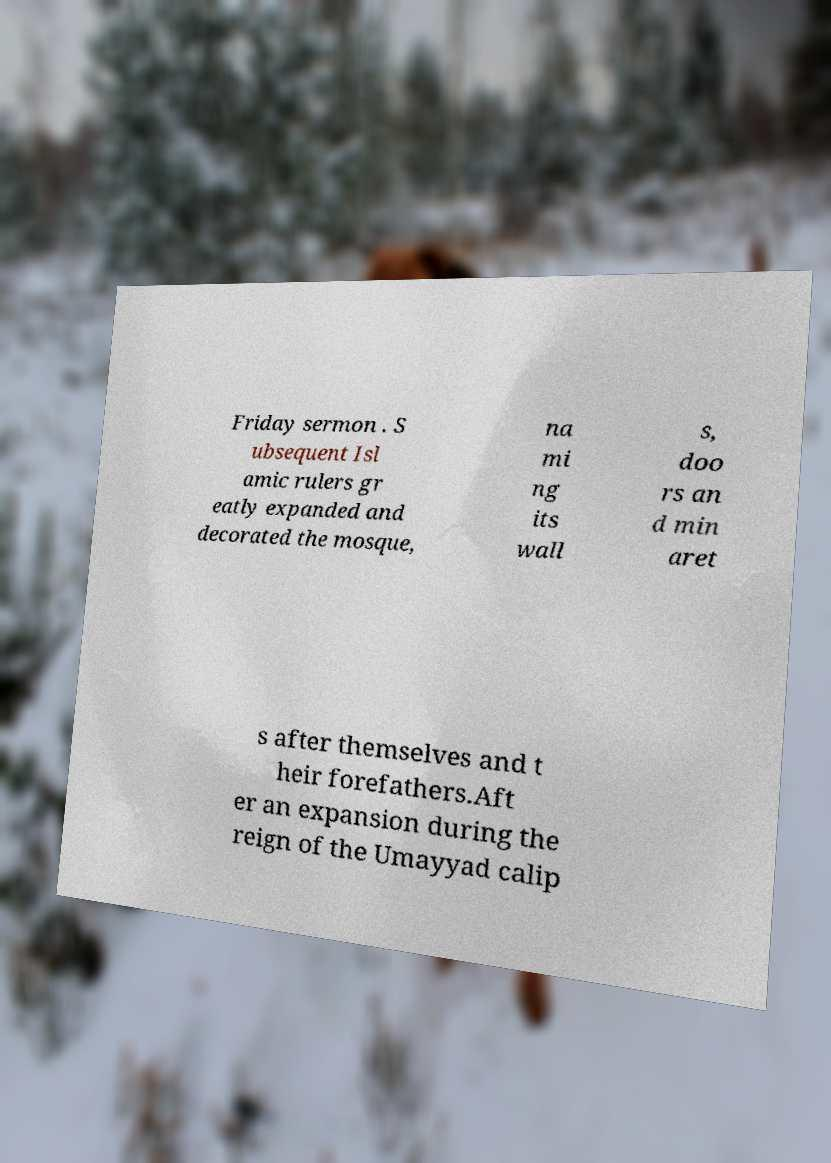Could you extract and type out the text from this image? Friday sermon . S ubsequent Isl amic rulers gr eatly expanded and decorated the mosque, na mi ng its wall s, doo rs an d min aret s after themselves and t heir forefathers.Aft er an expansion during the reign of the Umayyad calip 